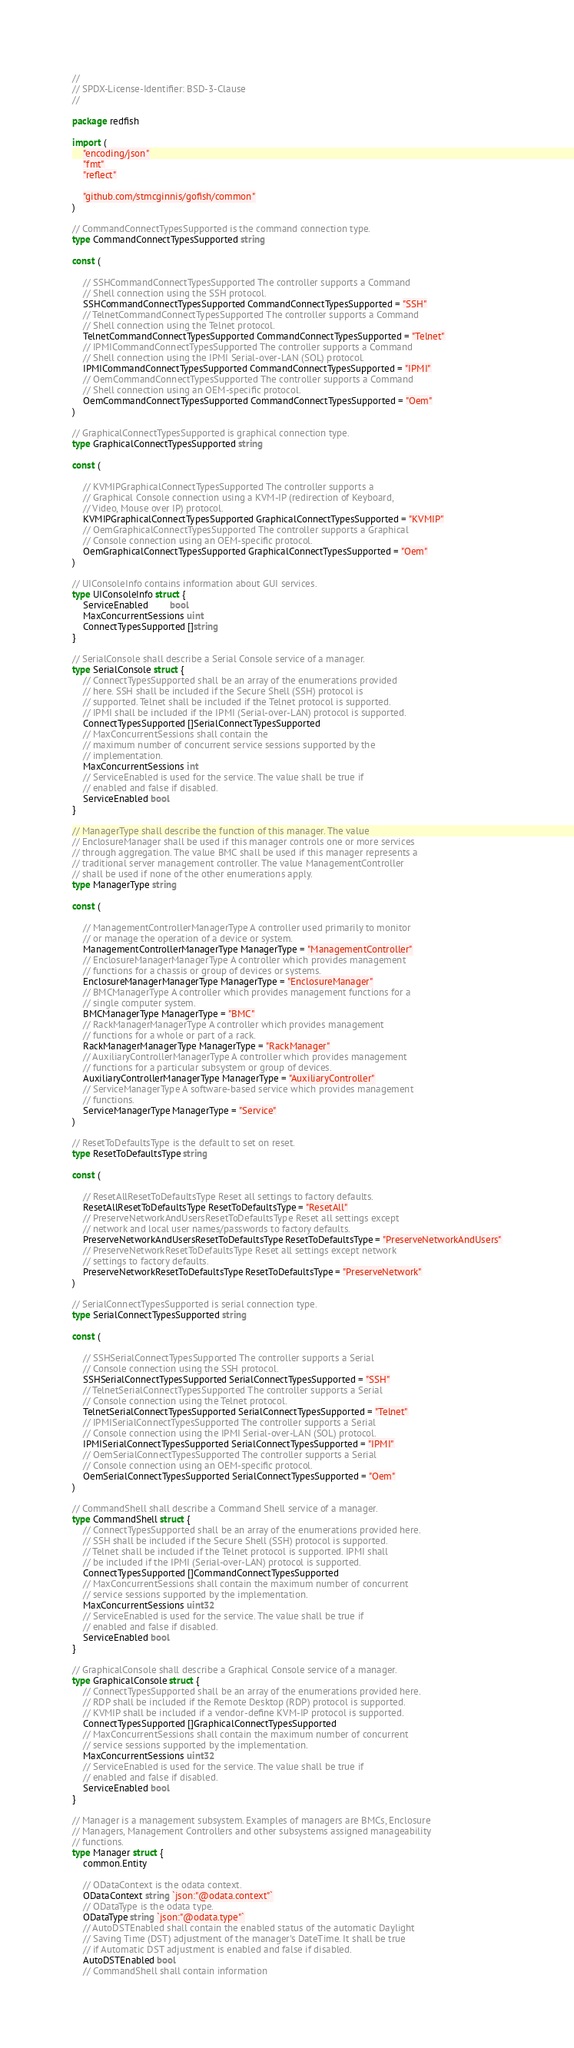Convert code to text. <code><loc_0><loc_0><loc_500><loc_500><_Go_>//
// SPDX-License-Identifier: BSD-3-Clause
//

package redfish

import (
	"encoding/json"
	"fmt"
	"reflect"

	"github.com/stmcginnis/gofish/common"
)

// CommandConnectTypesSupported is the command connection type.
type CommandConnectTypesSupported string

const (

	// SSHCommandConnectTypesSupported The controller supports a Command
	// Shell connection using the SSH protocol.
	SSHCommandConnectTypesSupported CommandConnectTypesSupported = "SSH"
	// TelnetCommandConnectTypesSupported The controller supports a Command
	// Shell connection using the Telnet protocol.
	TelnetCommandConnectTypesSupported CommandConnectTypesSupported = "Telnet"
	// IPMICommandConnectTypesSupported The controller supports a Command
	// Shell connection using the IPMI Serial-over-LAN (SOL) protocol.
	IPMICommandConnectTypesSupported CommandConnectTypesSupported = "IPMI"
	// OemCommandConnectTypesSupported The controller supports a Command
	// Shell connection using an OEM-specific protocol.
	OemCommandConnectTypesSupported CommandConnectTypesSupported = "Oem"
)

// GraphicalConnectTypesSupported is graphical connection type.
type GraphicalConnectTypesSupported string

const (

	// KVMIPGraphicalConnectTypesSupported The controller supports a
	// Graphical Console connection using a KVM-IP (redirection of Keyboard,
	// Video, Mouse over IP) protocol.
	KVMIPGraphicalConnectTypesSupported GraphicalConnectTypesSupported = "KVMIP"
	// OemGraphicalConnectTypesSupported The controller supports a Graphical
	// Console connection using an OEM-specific protocol.
	OemGraphicalConnectTypesSupported GraphicalConnectTypesSupported = "Oem"
)

// UIConsoleInfo contains information about GUI services.
type UIConsoleInfo struct {
	ServiceEnabled        bool
	MaxConcurrentSessions uint
	ConnectTypesSupported []string
}

// SerialConsole shall describe a Serial Console service of a manager.
type SerialConsole struct {
	// ConnectTypesSupported shall be an array of the enumerations provided
	// here. SSH shall be included if the Secure Shell (SSH) protocol is
	// supported. Telnet shall be included if the Telnet protocol is supported.
	// IPMI shall be included if the IPMI (Serial-over-LAN) protocol is supported.
	ConnectTypesSupported []SerialConnectTypesSupported
	// MaxConcurrentSessions shall contain the
	// maximum number of concurrent service sessions supported by the
	// implementation.
	MaxConcurrentSessions int
	// ServiceEnabled is used for the service. The value shall be true if
	// enabled and false if disabled.
	ServiceEnabled bool
}

// ManagerType shall describe the function of this manager. The value
// EnclosureManager shall be used if this manager controls one or more services
// through aggregation. The value BMC shall be used if this manager represents a
// traditional server management controller. The value ManagementController
// shall be used if none of the other enumerations apply.
type ManagerType string

const (

	// ManagementControllerManagerType A controller used primarily to monitor
	// or manage the operation of a device or system.
	ManagementControllerManagerType ManagerType = "ManagementController"
	// EnclosureManagerManagerType A controller which provides management
	// functions for a chassis or group of devices or systems.
	EnclosureManagerManagerType ManagerType = "EnclosureManager"
	// BMCManagerType A controller which provides management functions for a
	// single computer system.
	BMCManagerType ManagerType = "BMC"
	// RackManagerManagerType A controller which provides management
	// functions for a whole or part of a rack.
	RackManagerManagerType ManagerType = "RackManager"
	// AuxiliaryControllerManagerType A controller which provides management
	// functions for a particular subsystem or group of devices.
	AuxiliaryControllerManagerType ManagerType = "AuxiliaryController"
	// ServiceManagerType A software-based service which provides management
	// functions.
	ServiceManagerType ManagerType = "Service"
)

// ResetToDefaultsType is the default to set on reset.
type ResetToDefaultsType string

const (

	// ResetAllResetToDefaultsType Reset all settings to factory defaults.
	ResetAllResetToDefaultsType ResetToDefaultsType = "ResetAll"
	// PreserveNetworkAndUsersResetToDefaultsType Reset all settings except
	// network and local user names/passwords to factory defaults.
	PreserveNetworkAndUsersResetToDefaultsType ResetToDefaultsType = "PreserveNetworkAndUsers"
	// PreserveNetworkResetToDefaultsType Reset all settings except network
	// settings to factory defaults.
	PreserveNetworkResetToDefaultsType ResetToDefaultsType = "PreserveNetwork"
)

// SerialConnectTypesSupported is serial connection type.
type SerialConnectTypesSupported string

const (

	// SSHSerialConnectTypesSupported The controller supports a Serial
	// Console connection using the SSH protocol.
	SSHSerialConnectTypesSupported SerialConnectTypesSupported = "SSH"
	// TelnetSerialConnectTypesSupported The controller supports a Serial
	// Console connection using the Telnet protocol.
	TelnetSerialConnectTypesSupported SerialConnectTypesSupported = "Telnet"
	// IPMISerialConnectTypesSupported The controller supports a Serial
	// Console connection using the IPMI Serial-over-LAN (SOL) protocol.
	IPMISerialConnectTypesSupported SerialConnectTypesSupported = "IPMI"
	// OemSerialConnectTypesSupported The controller supports a Serial
	// Console connection using an OEM-specific protocol.
	OemSerialConnectTypesSupported SerialConnectTypesSupported = "Oem"
)

// CommandShell shall describe a Command Shell service of a manager.
type CommandShell struct {
	// ConnectTypesSupported shall be an array of the enumerations provided here.
	// SSH shall be included if the Secure Shell (SSH) protocol is supported.
	// Telnet shall be included if the Telnet protocol is supported. IPMI shall
	// be included if the IPMI (Serial-over-LAN) protocol is supported.
	ConnectTypesSupported []CommandConnectTypesSupported
	// MaxConcurrentSessions shall contain the maximum number of concurrent
	// service sessions supported by the implementation.
	MaxConcurrentSessions uint32
	// ServiceEnabled is used for the service. The value shall be true if
	// enabled and false if disabled.
	ServiceEnabled bool
}

// GraphicalConsole shall describe a Graphical Console service of a manager.
type GraphicalConsole struct {
	// ConnectTypesSupported shall be an array of the enumerations provided here.
	// RDP shall be included if the Remote Desktop (RDP) protocol is supported.
	// KVMIP shall be included if a vendor-define KVM-IP protocol is supported.
	ConnectTypesSupported []GraphicalConnectTypesSupported
	// MaxConcurrentSessions shall contain the maximum number of concurrent
	// service sessions supported by the implementation.
	MaxConcurrentSessions uint32
	// ServiceEnabled is used for the service. The value shall be true if
	// enabled and false if disabled.
	ServiceEnabled bool
}

// Manager is a management subsystem. Examples of managers are BMCs, Enclosure
// Managers, Management Controllers and other subsystems assigned manageability
// functions.
type Manager struct {
	common.Entity

	// ODataContext is the odata context.
	ODataContext string `json:"@odata.context"`
	// ODataType is the odata type.
	ODataType string `json:"@odata.type"`
	// AutoDSTEnabled shall contain the enabled status of the automatic Daylight
	// Saving Time (DST) adjustment of the manager's DateTime. It shall be true
	// if Automatic DST adjustment is enabled and false if disabled.
	AutoDSTEnabled bool
	// CommandShell shall contain information</code> 